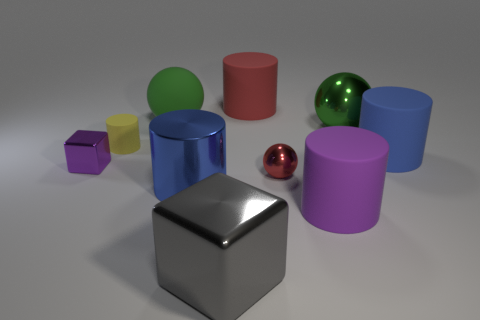Subtract all large metallic cylinders. How many cylinders are left? 4 Subtract all green spheres. How many spheres are left? 1 Subtract 3 cylinders. How many cylinders are left? 2 Subtract all cubes. How many objects are left? 8 Subtract all brown balls. Subtract all brown cylinders. How many balls are left? 3 Subtract all blue spheres. How many green cubes are left? 0 Subtract all purple metal things. Subtract all big red matte cylinders. How many objects are left? 8 Add 6 large green matte spheres. How many large green matte spheres are left? 7 Add 1 big green matte balls. How many big green matte balls exist? 2 Subtract 0 gray spheres. How many objects are left? 10 